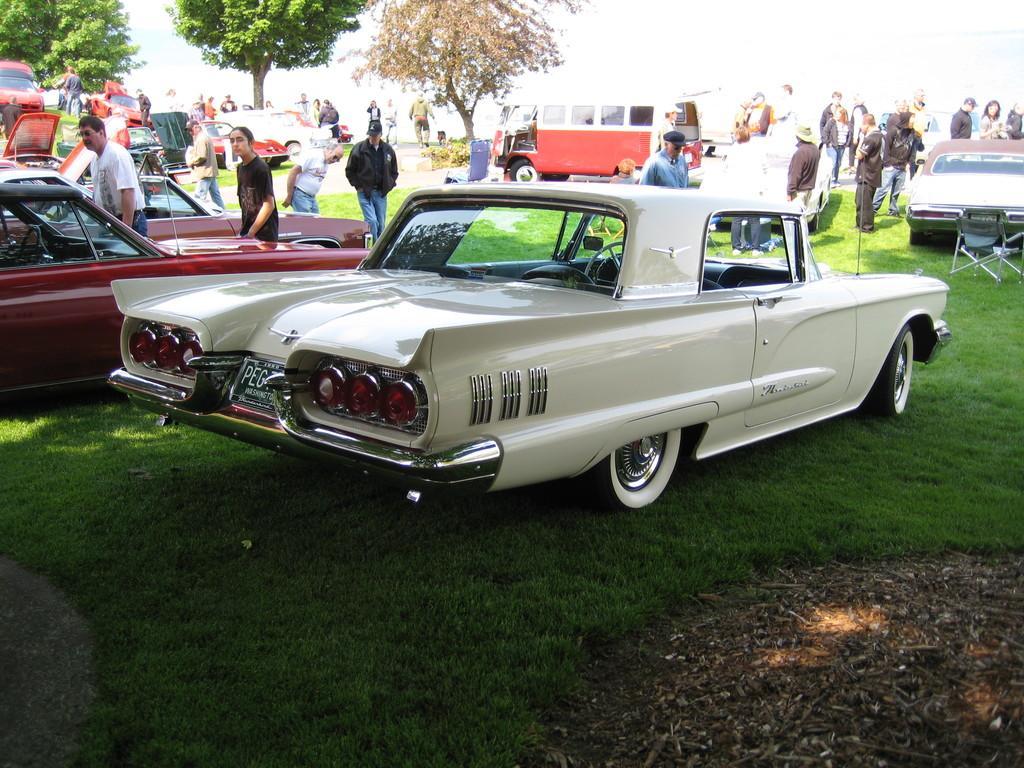Describe this image in one or two sentences. This picture is clicked outside. In the center we can see the group of vehicles and group of persons and we can see the green grass, chair and many other objects. In the background we can see the trees and some other objects and we can see there are some objects lying on the ground. 